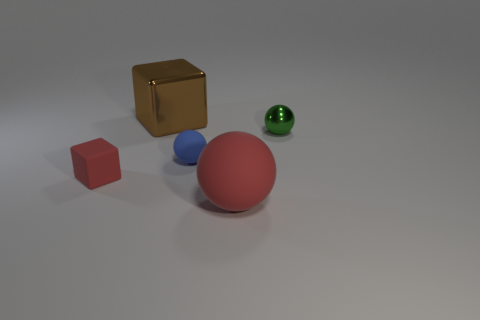Can you tell me about the composition and arrangement of objects in this image? Certainly! The image displays a collection of geometric objects arranged on a flat surface. From left to right, we see a gold cube, a red cube, a large red sphere, a smaller blue sphere, and a smaller green sphere with a matte texture. The arrangement creates a visually appealing contrast between shapes, sizes, and colors, possibly designed to examine the interplay of these elements in a simple, yet artistic representation. 